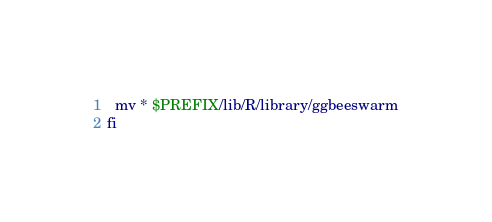<code> <loc_0><loc_0><loc_500><loc_500><_Bash_>  mv * $PREFIX/lib/R/library/ggbeeswarm
fi
</code> 